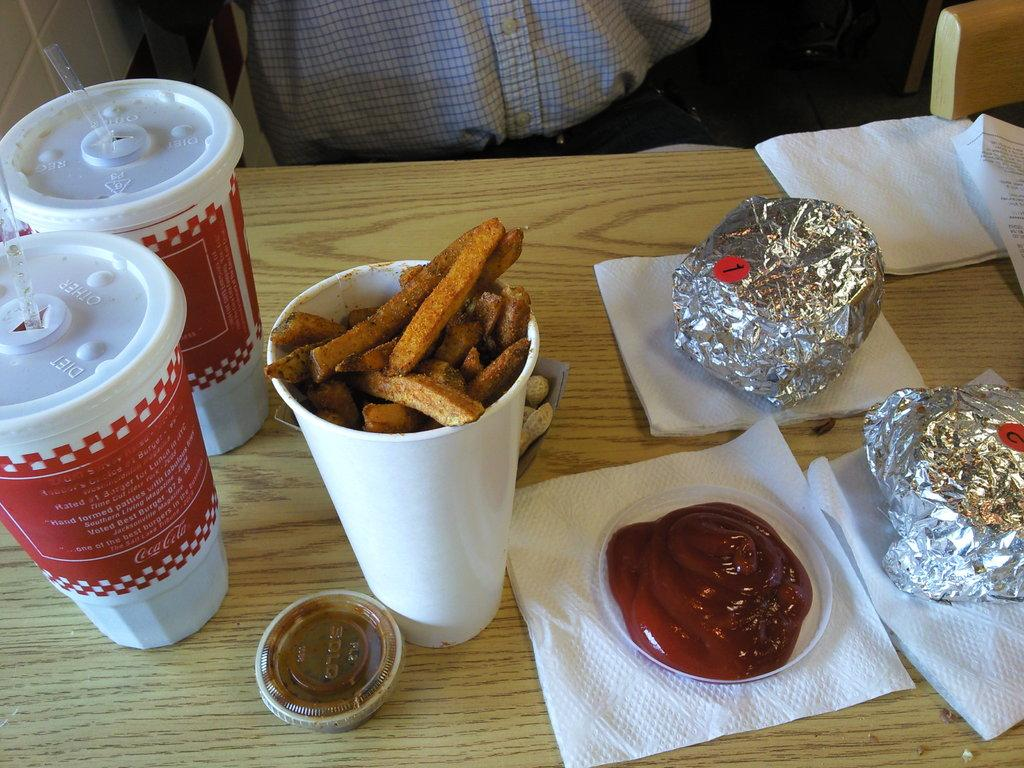What type of surface is visible in the image? There is a wooden surface in the image. What items can be seen on the wooden surface? There are tissues, a plate with sauce, a glass with potato wedges, glasses with straws and lids, and aluminium packets on the wooden surface. Can you describe the contents of the glass with potato wedges? The glass contains potato wedges. How are the glasses with straws and lids being used? The glasses with straws and lids are likely being used for drinking. What is the person visible in the background of the image doing? The facts provided do not give information about the person's actions or activities. What size is the rod used to stir the sauce in the image? There is no rod or stirring activity visible in the image. 